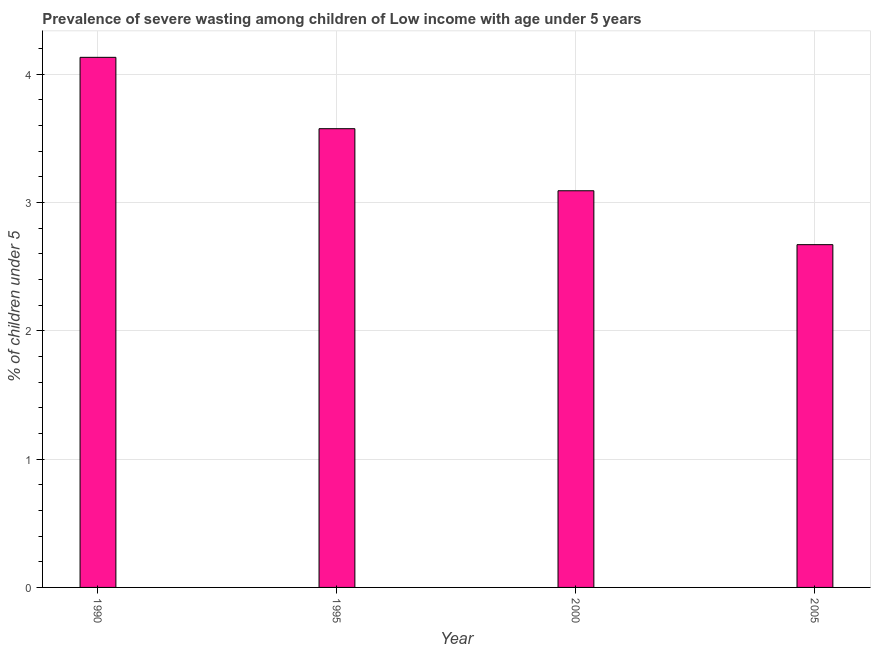Does the graph contain any zero values?
Provide a short and direct response. No. What is the title of the graph?
Your answer should be compact. Prevalence of severe wasting among children of Low income with age under 5 years. What is the label or title of the Y-axis?
Offer a terse response.  % of children under 5. What is the prevalence of severe wasting in 2005?
Make the answer very short. 2.67. Across all years, what is the maximum prevalence of severe wasting?
Your answer should be very brief. 4.13. Across all years, what is the minimum prevalence of severe wasting?
Make the answer very short. 2.67. In which year was the prevalence of severe wasting minimum?
Your response must be concise. 2005. What is the sum of the prevalence of severe wasting?
Offer a terse response. 13.47. What is the average prevalence of severe wasting per year?
Offer a terse response. 3.37. What is the median prevalence of severe wasting?
Provide a succinct answer. 3.33. In how many years, is the prevalence of severe wasting greater than 2.4 %?
Provide a succinct answer. 4. Do a majority of the years between 2000 and 1995 (inclusive) have prevalence of severe wasting greater than 1.6 %?
Keep it short and to the point. No. What is the ratio of the prevalence of severe wasting in 1990 to that in 2000?
Offer a very short reply. 1.34. Is the prevalence of severe wasting in 1990 less than that in 2000?
Your response must be concise. No. Is the difference between the prevalence of severe wasting in 1995 and 2005 greater than the difference between any two years?
Your answer should be compact. No. What is the difference between the highest and the second highest prevalence of severe wasting?
Your answer should be very brief. 0.56. Is the sum of the prevalence of severe wasting in 1990 and 2000 greater than the maximum prevalence of severe wasting across all years?
Provide a succinct answer. Yes. What is the difference between the highest and the lowest prevalence of severe wasting?
Your answer should be compact. 1.46. In how many years, is the prevalence of severe wasting greater than the average prevalence of severe wasting taken over all years?
Keep it short and to the point. 2. How many bars are there?
Your response must be concise. 4. What is the  % of children under 5 in 1990?
Ensure brevity in your answer.  4.13. What is the  % of children under 5 in 1995?
Offer a very short reply. 3.57. What is the  % of children under 5 of 2000?
Provide a short and direct response. 3.09. What is the  % of children under 5 of 2005?
Offer a terse response. 2.67. What is the difference between the  % of children under 5 in 1990 and 1995?
Ensure brevity in your answer.  0.56. What is the difference between the  % of children under 5 in 1990 and 2000?
Offer a terse response. 1.04. What is the difference between the  % of children under 5 in 1990 and 2005?
Provide a succinct answer. 1.46. What is the difference between the  % of children under 5 in 1995 and 2000?
Give a very brief answer. 0.48. What is the difference between the  % of children under 5 in 1995 and 2005?
Provide a short and direct response. 0.9. What is the difference between the  % of children under 5 in 2000 and 2005?
Offer a terse response. 0.42. What is the ratio of the  % of children under 5 in 1990 to that in 1995?
Offer a very short reply. 1.16. What is the ratio of the  % of children under 5 in 1990 to that in 2000?
Provide a short and direct response. 1.34. What is the ratio of the  % of children under 5 in 1990 to that in 2005?
Offer a terse response. 1.55. What is the ratio of the  % of children under 5 in 1995 to that in 2000?
Your answer should be very brief. 1.16. What is the ratio of the  % of children under 5 in 1995 to that in 2005?
Keep it short and to the point. 1.34. What is the ratio of the  % of children under 5 in 2000 to that in 2005?
Give a very brief answer. 1.16. 